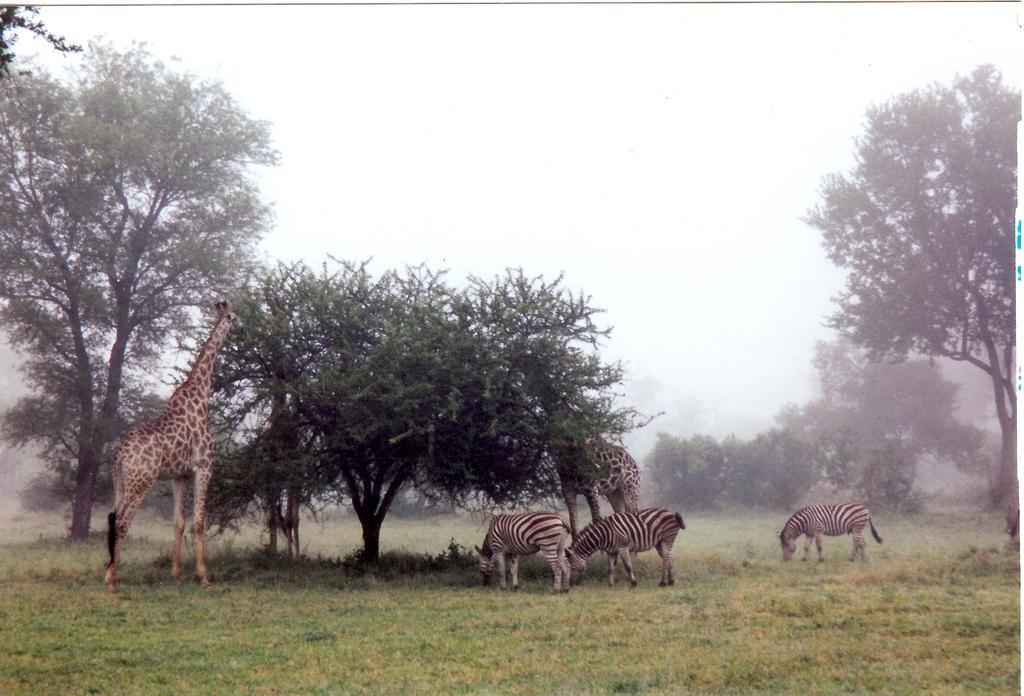Please provide a concise description of this image. In this image there are zebras and giraffes standing on the ground. There is grass on the ground. Behind them there are trees. At the top there is the sky. There is the fog in the image. 